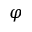<formula> <loc_0><loc_0><loc_500><loc_500>\varphi</formula> 